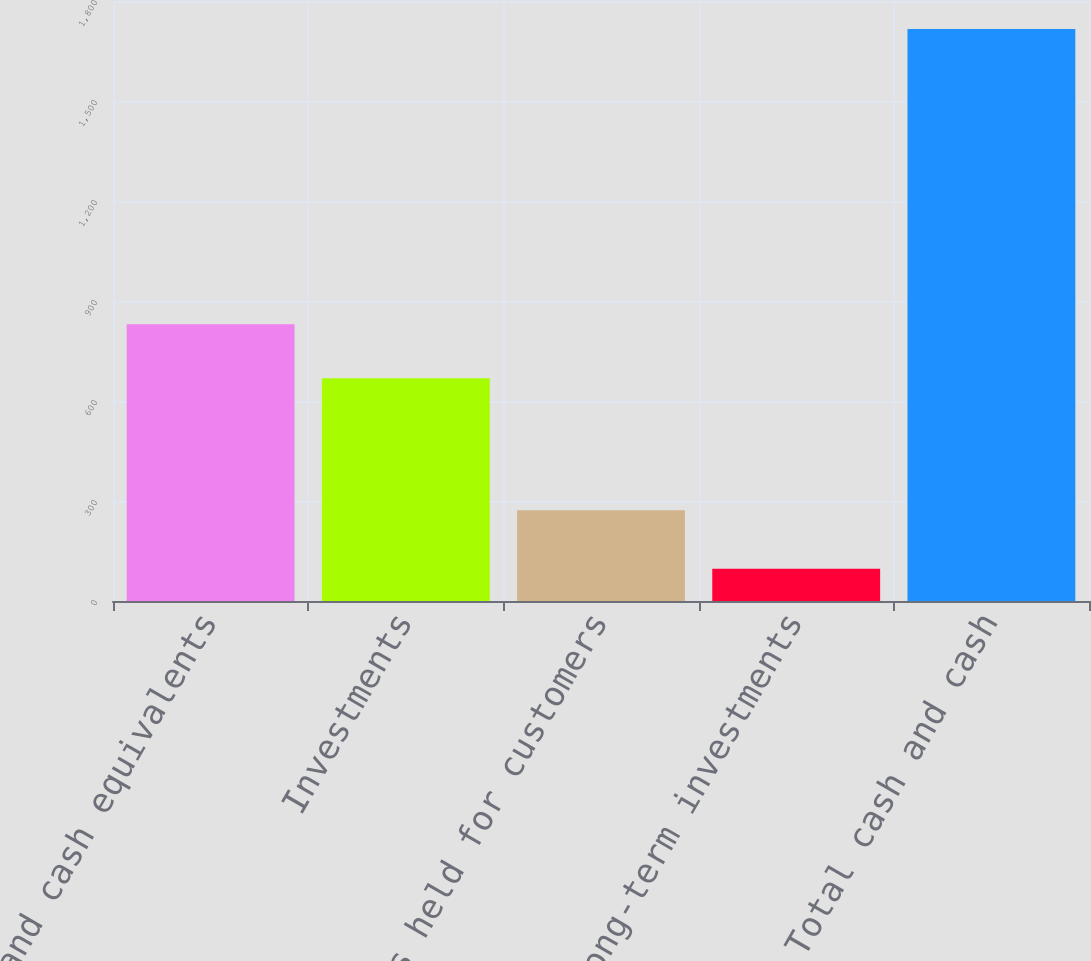Convert chart. <chart><loc_0><loc_0><loc_500><loc_500><bar_chart><fcel>Cash and cash equivalents<fcel>Investments<fcel>Funds held for customers<fcel>Long-term investments<fcel>Total cash and cash<nl><fcel>829.9<fcel>668<fcel>272<fcel>97<fcel>1716<nl></chart> 